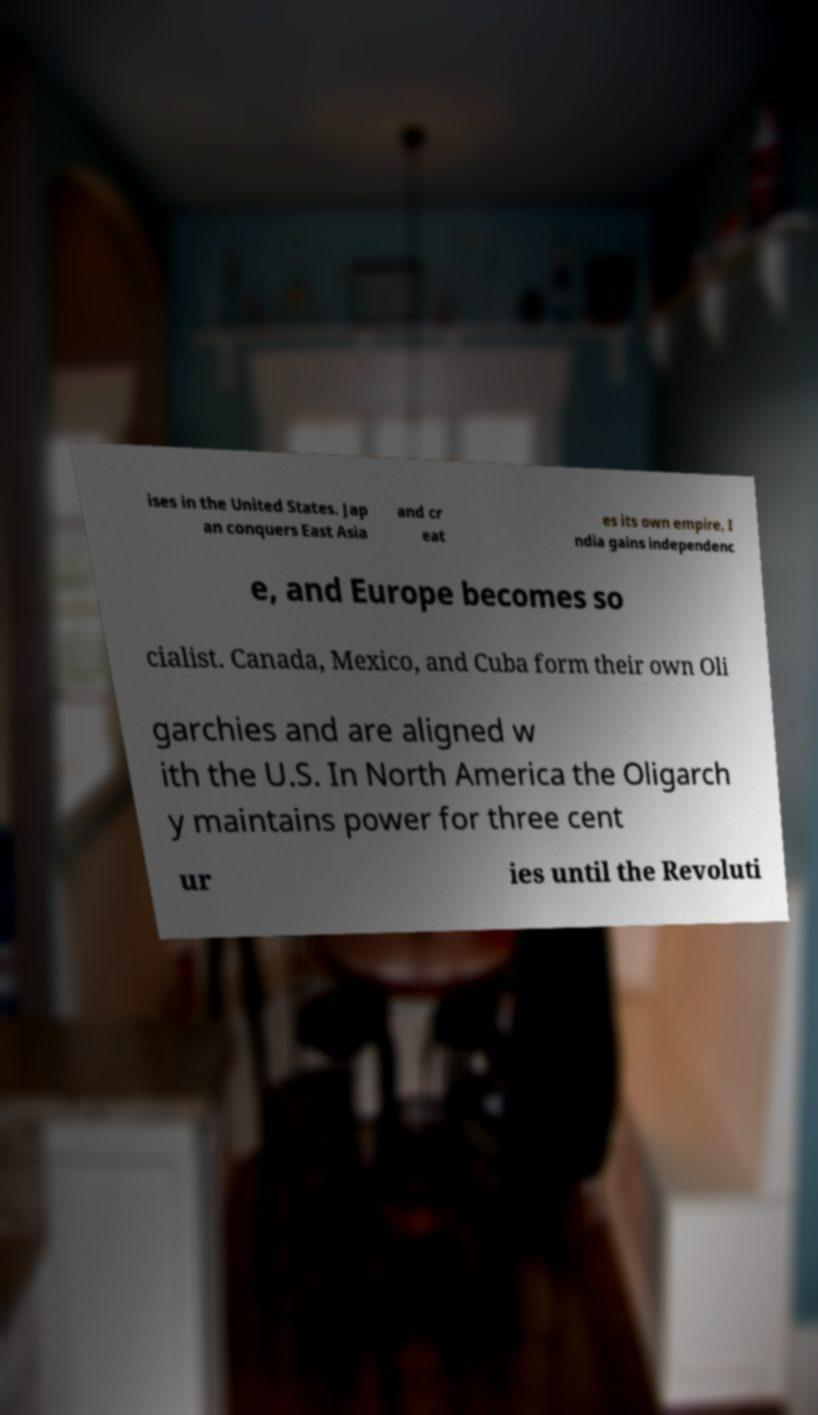Please read and relay the text visible in this image. What does it say? ises in the United States. Jap an conquers East Asia and cr eat es its own empire, I ndia gains independenc e, and Europe becomes so cialist. Canada, Mexico, and Cuba form their own Oli garchies and are aligned w ith the U.S. In North America the Oligarch y maintains power for three cent ur ies until the Revoluti 